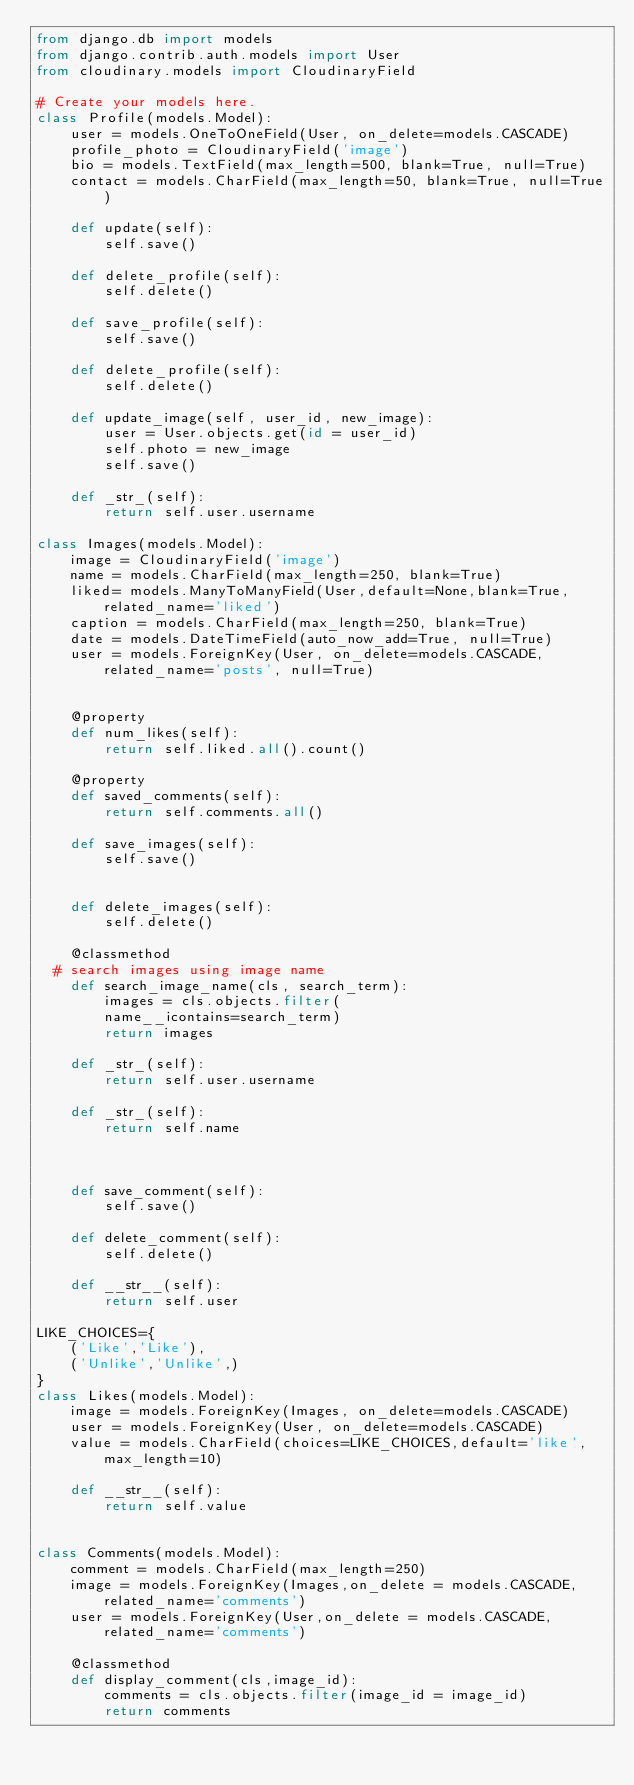Convert code to text. <code><loc_0><loc_0><loc_500><loc_500><_Python_>from django.db import models
from django.contrib.auth.models import User
from cloudinary.models import CloudinaryField

# Create your models here.
class Profile(models.Model):
    user = models.OneToOneField(User, on_delete=models.CASCADE)
    profile_photo = CloudinaryField('image')
    bio = models.TextField(max_length=500, blank=True, null=True)
    contact = models.CharField(max_length=50, blank=True, null=True)

    def update(self):
        self.save()

    def delete_profile(self):
        self.delete()

    def save_profile(self):
        self.save() 

    def delete_profile(self):
        self.delete()

    def update_image(self, user_id, new_image):
        user = User.objects.get(id = user_id)
        self.photo = new_image 
        self.save()

    def _str_(self):
        return self.user.username

class Images(models.Model):
    image = CloudinaryField('image')
    name = models.CharField(max_length=250, blank=True)
    liked= models.ManyToManyField(User,default=None,blank=True,related_name='liked')
    caption = models.CharField(max_length=250, blank=True)
    date = models.DateTimeField(auto_now_add=True, null=True)
    user = models.ForeignKey(User, on_delete=models.CASCADE, related_name='posts', null=True)
    

    @property
    def num_likes(self):
        return self.liked.all().count()

    @property
    def saved_comments(self):
        return self.comments.all()    

    def save_images(self):
        self.save()
    
     
    def delete_images(self):
        self.delete()

    @classmethod
  # search images using image name
    def search_image_name(cls, search_term):
        images = cls.objects.filter(
        name__icontains=search_term)
        return images    

    def _str_(self):
        return self.user.username       

    def _str_(self):
        return self.name



    def save_comment(self):
        self.save()
    
    def delete_comment(self):
        self.delete()

    def __str__(self):
        return self.user

LIKE_CHOICES={
    ('Like','Like'),
    ('Unlike','Unlike',)
}
class Likes(models.Model):
    image = models.ForeignKey(Images, on_delete=models.CASCADE)
    user = models.ForeignKey(User, on_delete=models.CASCADE)
    value = models.CharField(choices=LIKE_CHOICES,default='like',max_length=10)

    def __str__(self):
        return self.value

          
class Comments(models.Model):
    comment = models.CharField(max_length=250)
    image = models.ForeignKey(Images,on_delete = models.CASCADE,related_name='comments')
    user = models.ForeignKey(User,on_delete = models.CASCADE,related_name='comments')

    @classmethod
    def display_comment(cls,image_id):
        comments = cls.objects.filter(image_id = image_id)
        return comments


   
    
    
  </code> 